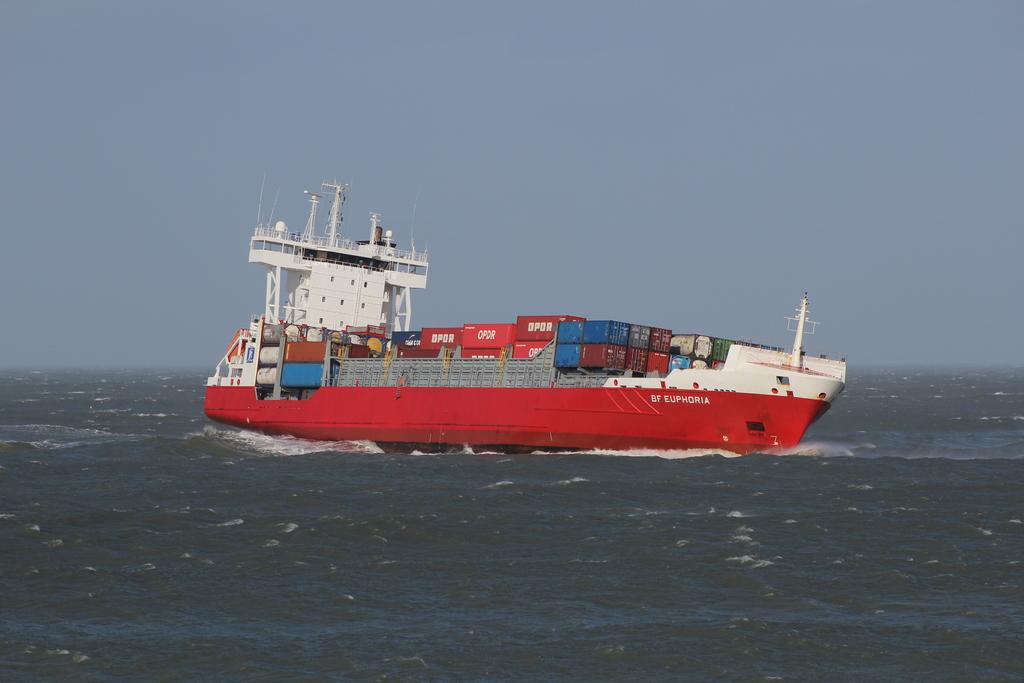What is the main subject of the image? There is a ship in the image. Can you describe the ship's position in relation to the water? The ship is above the water. What can be seen in the background of the image? The sky is visible in the background of the image. Are there any masks being used by the crew on the ship in the image? There is no information about the crew or any masks in the image; it only shows the ship above the water with the sky in the background. 